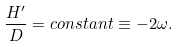<formula> <loc_0><loc_0><loc_500><loc_500>\frac { H ^ { \prime } } { D } = c o n s t a n t \equiv - 2 \omega .</formula> 